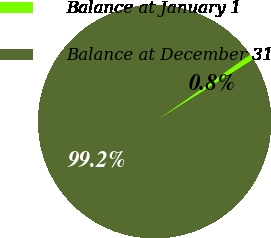<chart> <loc_0><loc_0><loc_500><loc_500><pie_chart><fcel>Balance at January 1<fcel>Balance at December 31<nl><fcel>0.78%<fcel>99.22%<nl></chart> 